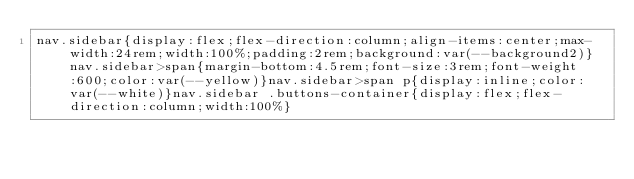<code> <loc_0><loc_0><loc_500><loc_500><_CSS_>nav.sidebar{display:flex;flex-direction:column;align-items:center;max-width:24rem;width:100%;padding:2rem;background:var(--background2)}nav.sidebar>span{margin-bottom:4.5rem;font-size:3rem;font-weight:600;color:var(--yellow)}nav.sidebar>span p{display:inline;color:var(--white)}nav.sidebar .buttons-container{display:flex;flex-direction:column;width:100%}
</code> 